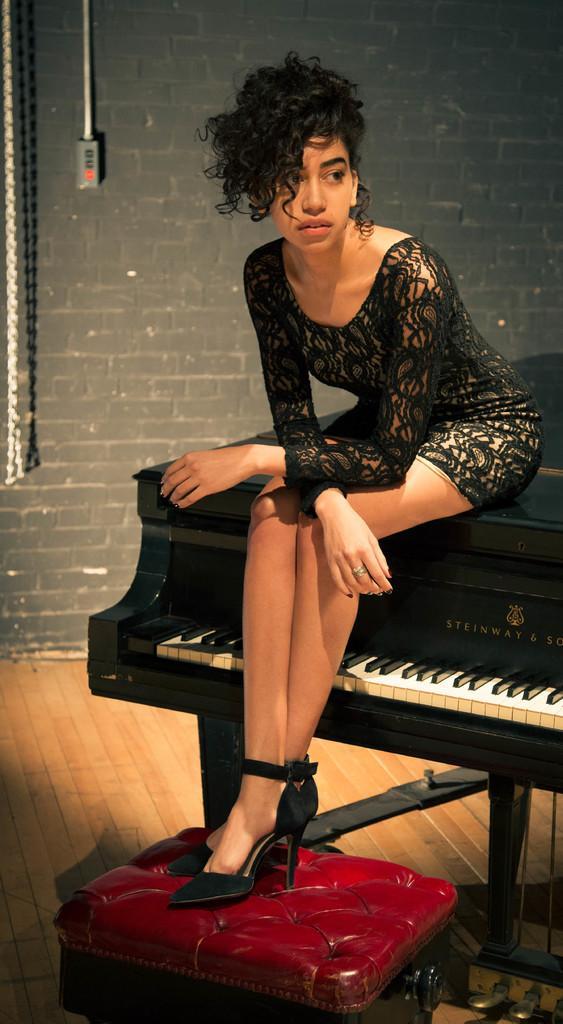Could you give a brief overview of what you see in this image? In this image I see a woman who is sitting on the keyboard and there is a stool over here, In the background I see the wall and she is wearing a black dress 